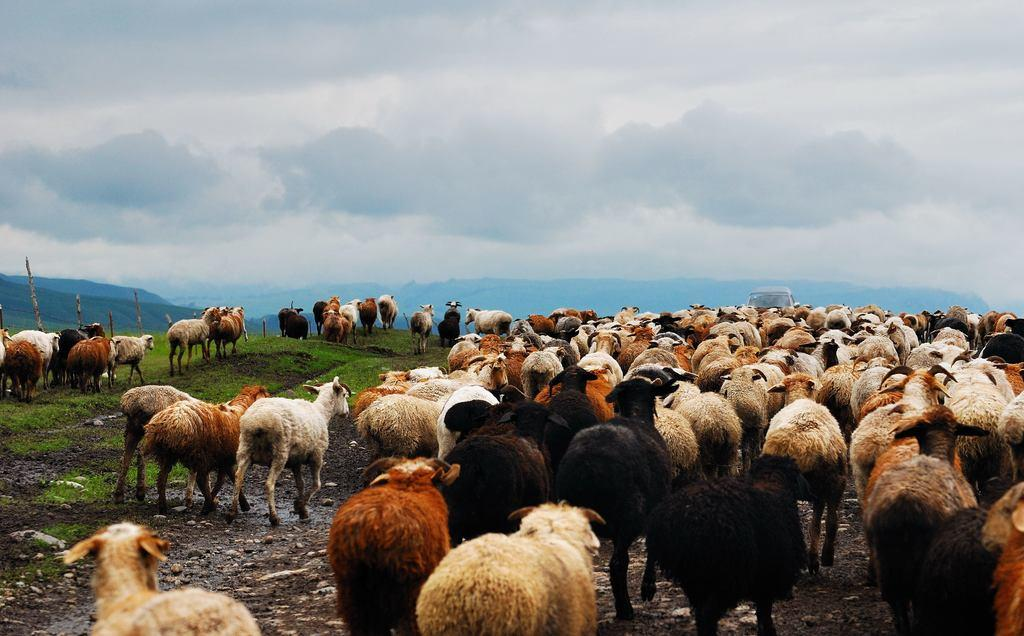What is the main subject of the image? There is a group of animals in the image. What colors are the animals in the image? The animals are in black, white, and brown colors. What can be seen in the background of the image? There are mountains and wooden logs visible in the background of the image. What is the color of the sky in the image? The sky is white in color. What type of carpenter is working on the scene in the image? There is no carpenter present in the image; it features a group of animals in front of mountains and wooden logs. What form does the scene take in the image? The scene in the image is a natural landscape with animals, mountains, wooden logs, and a white sky. 